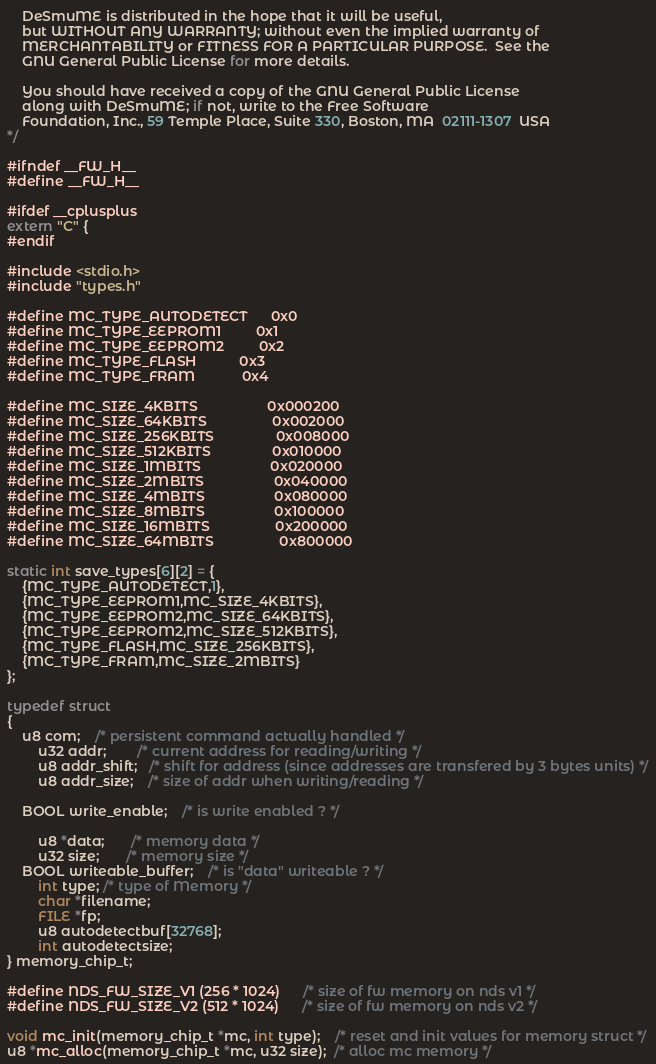<code> <loc_0><loc_0><loc_500><loc_500><_C_>    DeSmuME is distributed in the hope that it will be useful,
    but WITHOUT ANY WARRANTY; without even the implied warranty of
    MERCHANTABILITY or FITNESS FOR A PARTICULAR PURPOSE.  See the
    GNU General Public License for more details.

    You should have received a copy of the GNU General Public License
    along with DeSmuME; if not, write to the Free Software
    Foundation, Inc., 59 Temple Place, Suite 330, Boston, MA  02111-1307  USA
*/

#ifndef __FW_H__
#define __FW_H__

#ifdef __cplusplus
extern "C" {
#endif

#include <stdio.h>
#include "types.h"

#define MC_TYPE_AUTODETECT      0x0
#define MC_TYPE_EEPROM1         0x1
#define MC_TYPE_EEPROM2         0x2
#define MC_TYPE_FLASH           0x3
#define MC_TYPE_FRAM            0x4

#define MC_SIZE_4KBITS                  0x000200
#define MC_SIZE_64KBITS                 0x002000
#define MC_SIZE_256KBITS                0x008000
#define MC_SIZE_512KBITS                0x010000
#define MC_SIZE_1MBITS                  0x020000
#define MC_SIZE_2MBITS                  0x040000
#define MC_SIZE_4MBITS                  0x080000
#define MC_SIZE_8MBITS                  0x100000
#define MC_SIZE_16MBITS                 0x200000
#define MC_SIZE_64MBITS                 0x800000

static int save_types[6][2] = {
	{MC_TYPE_AUTODETECT,1},
	{MC_TYPE_EEPROM1,MC_SIZE_4KBITS},
	{MC_TYPE_EEPROM2,MC_SIZE_64KBITS},
	{MC_TYPE_EEPROM2,MC_SIZE_512KBITS},
	{MC_TYPE_FLASH,MC_SIZE_256KBITS},
	{MC_TYPE_FRAM,MC_SIZE_2MBITS}
};

typedef struct
{
	u8 com;	/* persistent command actually handled */
        u32 addr;        /* current address for reading/writing */
        u8 addr_shift;   /* shift for address (since addresses are transfered by 3 bytes units) */
        u8 addr_size;    /* size of addr when writing/reading */
	
	BOOL write_enable;	/* is write enabled ? */
	
        u8 *data;       /* memory data */
        u32 size;       /* memory size */
	BOOL writeable_buffer;	/* is "data" writeable ? */
        int type; /* type of Memory */
        char *filename;
        FILE *fp;
        u8 autodetectbuf[32768];
        int autodetectsize;
} memory_chip_t;

#define NDS_FW_SIZE_V1 (256 * 1024)		/* size of fw memory on nds v1 */
#define NDS_FW_SIZE_V2 (512 * 1024)		/* size of fw memory on nds v2 */

void mc_init(memory_chip_t *mc, int type);    /* reset and init values for memory struct */
u8 *mc_alloc(memory_chip_t *mc, u32 size);  /* alloc mc memory */</code> 